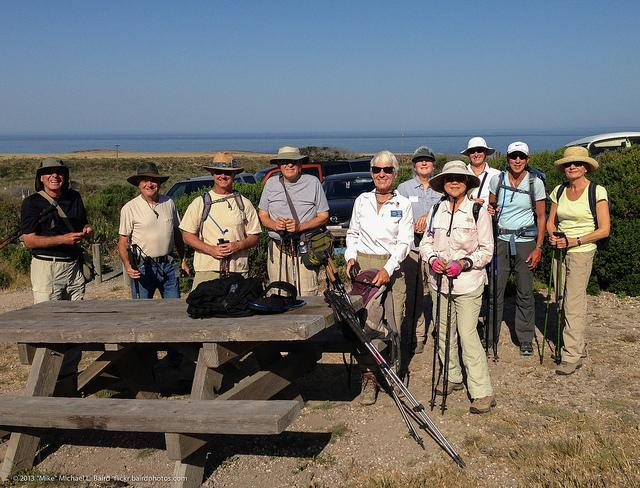What activity is this group preparing for? Please explain your reasoning. hiking. The activity is hiking. 